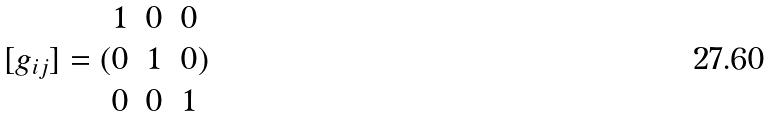Convert formula to latex. <formula><loc_0><loc_0><loc_500><loc_500>[ g _ { i j } ] = ( \begin{matrix} 1 & 0 & 0 \\ 0 & 1 & 0 \\ 0 & 0 & 1 \end{matrix} )</formula> 